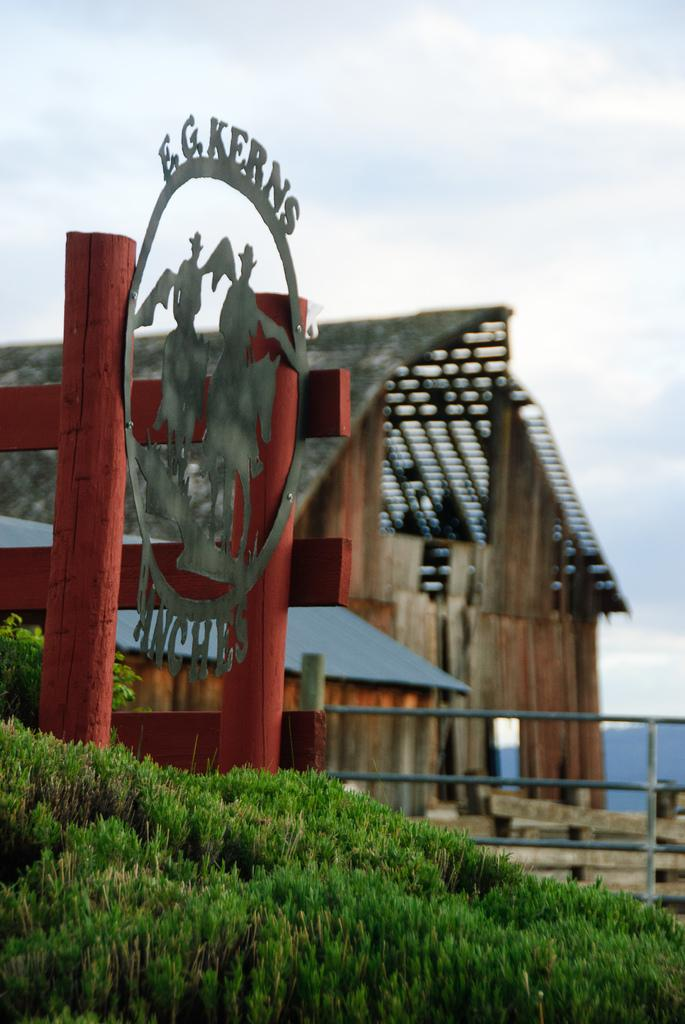What type of vegetation can be seen in the image? There is grass in the image. What type of barrier is present in the image? There is a fence in the image. What type of building is visible in the image? There is a shed in the image. What is written on the board in the image? The board has a name on it. What can be seen in the background of the image? The sky is visible in the background of the image, and there are clouds in the sky. How many pieces of lumber are stacked near the shed in the image? There is no lumber visible in the image; only a shed, grass, fence, and board with a name are present. What type of animal can be seen grazing on the grass in the image? There are no animals visible in the image; only a shed, grass, fence, and board with a name are present. 